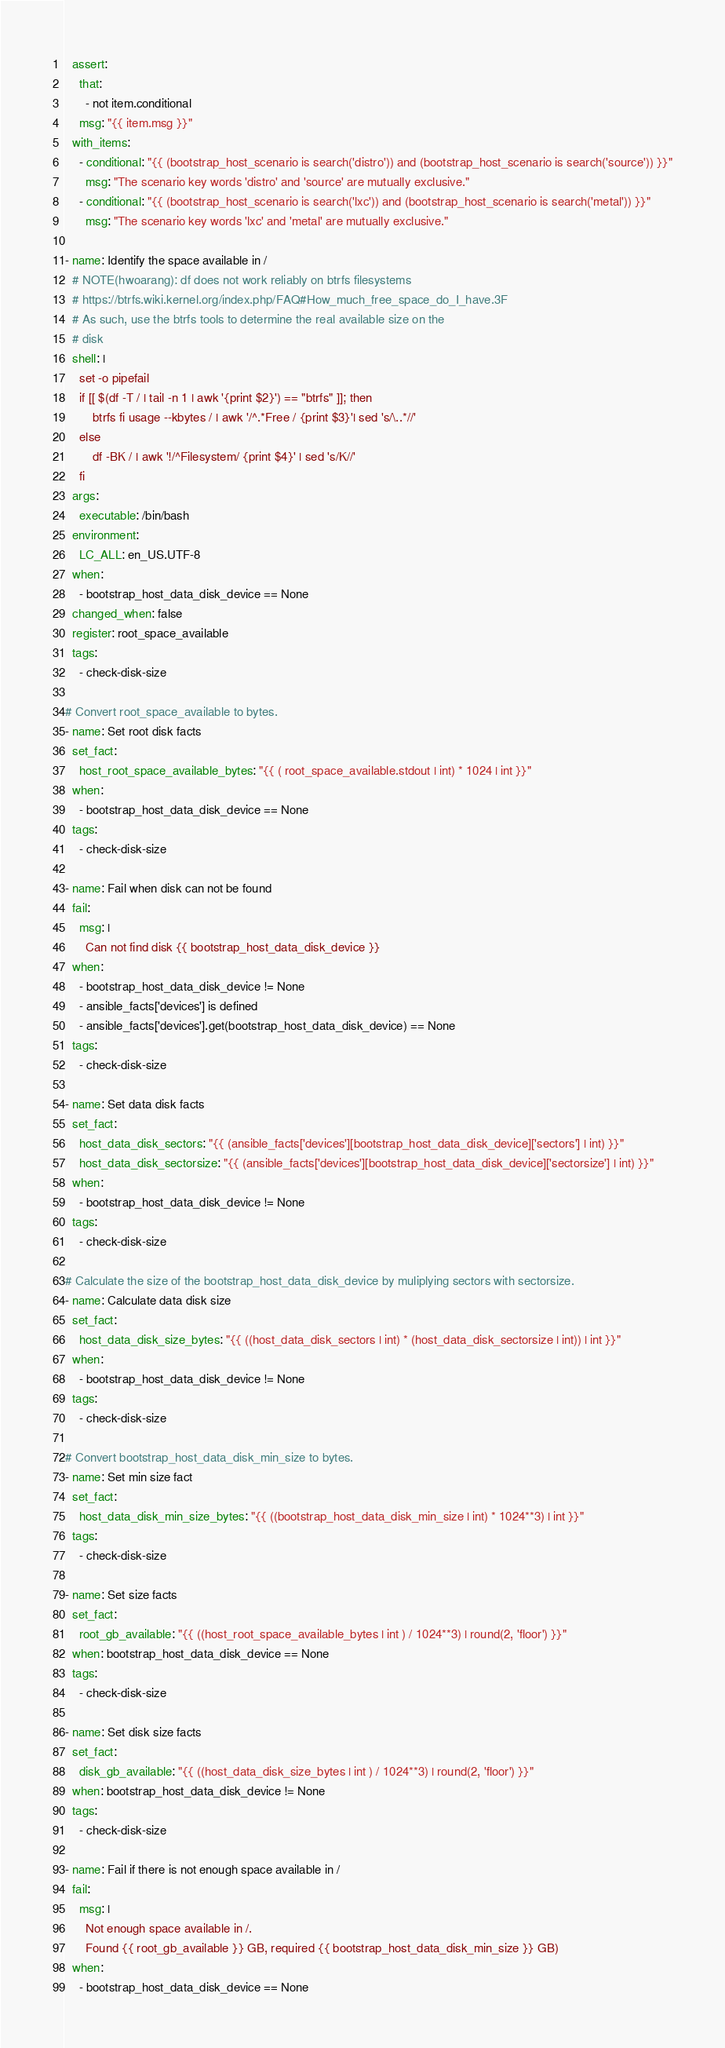Convert code to text. <code><loc_0><loc_0><loc_500><loc_500><_YAML_>  assert:
    that:
      - not item.conditional
    msg: "{{ item.msg }}"
  with_items:
    - conditional: "{{ (bootstrap_host_scenario is search('distro')) and (bootstrap_host_scenario is search('source')) }}"
      msg: "The scenario key words 'distro' and 'source' are mutually exclusive."
    - conditional: "{{ (bootstrap_host_scenario is search('lxc')) and (bootstrap_host_scenario is search('metal')) }}"
      msg: "The scenario key words 'lxc' and 'metal' are mutually exclusive."

- name: Identify the space available in /
  # NOTE(hwoarang): df does not work reliably on btrfs filesystems
  # https://btrfs.wiki.kernel.org/index.php/FAQ#How_much_free_space_do_I_have.3F
  # As such, use the btrfs tools to determine the real available size on the
  # disk
  shell: |
    set -o pipefail
    if [[ $(df -T / | tail -n 1 | awk '{print $2}') == "btrfs" ]]; then
        btrfs fi usage --kbytes / | awk '/^.*Free / {print $3}'| sed 's/\..*//'
    else
        df -BK / | awk '!/^Filesystem/ {print $4}' | sed 's/K//'
    fi
  args:
    executable: /bin/bash
  environment:
    LC_ALL: en_US.UTF-8
  when:
    - bootstrap_host_data_disk_device == None
  changed_when: false
  register: root_space_available
  tags:
    - check-disk-size

# Convert root_space_available to bytes.
- name: Set root disk facts
  set_fact:
    host_root_space_available_bytes: "{{ ( root_space_available.stdout | int) * 1024 | int }}"
  when:
    - bootstrap_host_data_disk_device == None
  tags:
    - check-disk-size

- name: Fail when disk can not be found
  fail:
    msg: |
      Can not find disk {{ bootstrap_host_data_disk_device }}
  when:
    - bootstrap_host_data_disk_device != None
    - ansible_facts['devices'] is defined
    - ansible_facts['devices'].get(bootstrap_host_data_disk_device) == None
  tags:
    - check-disk-size

- name: Set data disk facts
  set_fact:
    host_data_disk_sectors: "{{ (ansible_facts['devices'][bootstrap_host_data_disk_device]['sectors'] | int) }}"
    host_data_disk_sectorsize: "{{ (ansible_facts['devices'][bootstrap_host_data_disk_device]['sectorsize'] | int) }}"
  when:
    - bootstrap_host_data_disk_device != None
  tags:
    - check-disk-size

# Calculate the size of the bootstrap_host_data_disk_device by muliplying sectors with sectorsize.
- name: Calculate data disk size
  set_fact:
    host_data_disk_size_bytes: "{{ ((host_data_disk_sectors | int) * (host_data_disk_sectorsize | int)) | int }}"
  when:
    - bootstrap_host_data_disk_device != None
  tags:
    - check-disk-size

# Convert bootstrap_host_data_disk_min_size to bytes.
- name: Set min size fact
  set_fact:
    host_data_disk_min_size_bytes: "{{ ((bootstrap_host_data_disk_min_size | int) * 1024**3) | int }}"
  tags:
    - check-disk-size

- name: Set size facts
  set_fact:
    root_gb_available: "{{ ((host_root_space_available_bytes | int ) / 1024**3) | round(2, 'floor') }}"
  when: bootstrap_host_data_disk_device == None
  tags:
    - check-disk-size

- name: Set disk size facts
  set_fact:
    disk_gb_available: "{{ ((host_data_disk_size_bytes | int ) / 1024**3) | round(2, 'floor') }}"
  when: bootstrap_host_data_disk_device != None
  tags:
    - check-disk-size

- name: Fail if there is not enough space available in /
  fail:
    msg: |
      Not enough space available in /.
      Found {{ root_gb_available }} GB, required {{ bootstrap_host_data_disk_min_size }} GB)
  when:
    - bootstrap_host_data_disk_device == None</code> 